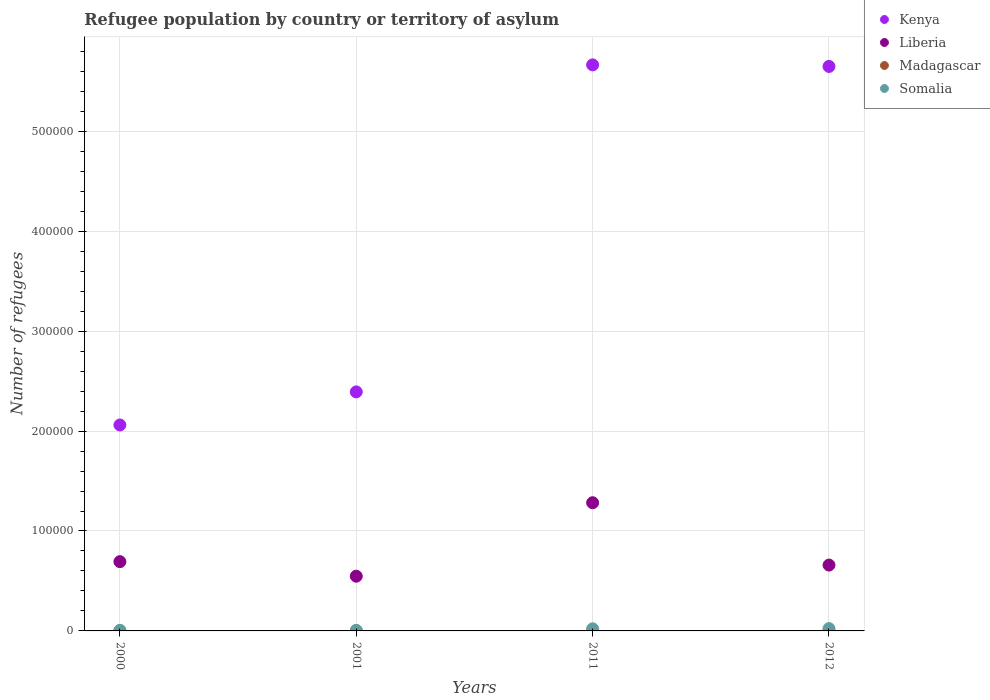How many different coloured dotlines are there?
Make the answer very short. 4. What is the number of refugees in Liberia in 2001?
Provide a succinct answer. 5.48e+04. Across all years, what is the maximum number of refugees in Kenya?
Your answer should be very brief. 5.66e+05. Across all years, what is the minimum number of refugees in Madagascar?
Your answer should be very brief. 9. What is the total number of refugees in Liberia in the graph?
Your response must be concise. 3.18e+05. What is the difference between the number of refugees in Somalia in 2001 and that in 2012?
Your answer should be very brief. -1720. What is the difference between the number of refugees in Liberia in 2000 and the number of refugees in Madagascar in 2012?
Your answer should be compact. 6.93e+04. In the year 2000, what is the difference between the number of refugees in Somalia and number of refugees in Madagascar?
Provide a short and direct response. 508. What is the ratio of the number of refugees in Somalia in 2000 to that in 2012?
Your answer should be compact. 0.24. Is the difference between the number of refugees in Somalia in 2001 and 2012 greater than the difference between the number of refugees in Madagascar in 2001 and 2012?
Your answer should be very brief. No. What is the difference between the highest and the second highest number of refugees in Kenya?
Offer a very short reply. 1554. What is the difference between the highest and the lowest number of refugees in Kenya?
Give a very brief answer. 3.60e+05. In how many years, is the number of refugees in Madagascar greater than the average number of refugees in Madagascar taken over all years?
Ensure brevity in your answer.  2. Is the sum of the number of refugees in Somalia in 2001 and 2012 greater than the maximum number of refugees in Liberia across all years?
Make the answer very short. No. Does the number of refugees in Kenya monotonically increase over the years?
Your response must be concise. No. Is the number of refugees in Liberia strictly less than the number of refugees in Somalia over the years?
Make the answer very short. No. How many dotlines are there?
Offer a terse response. 4. How many years are there in the graph?
Keep it short and to the point. 4. What is the difference between two consecutive major ticks on the Y-axis?
Make the answer very short. 1.00e+05. Are the values on the major ticks of Y-axis written in scientific E-notation?
Provide a short and direct response. No. Does the graph contain grids?
Your response must be concise. Yes. How many legend labels are there?
Your response must be concise. 4. What is the title of the graph?
Your answer should be very brief. Refugee population by country or territory of asylum. Does "Somalia" appear as one of the legend labels in the graph?
Provide a succinct answer. Yes. What is the label or title of the Y-axis?
Your answer should be compact. Number of refugees. What is the Number of refugees in Kenya in 2000?
Provide a short and direct response. 2.06e+05. What is the Number of refugees in Liberia in 2000?
Offer a terse response. 6.93e+04. What is the Number of refugees of Madagascar in 2000?
Your answer should be compact. 50. What is the Number of refugees in Somalia in 2000?
Give a very brief answer. 558. What is the Number of refugees of Kenya in 2001?
Your response must be concise. 2.39e+05. What is the Number of refugees in Liberia in 2001?
Offer a terse response. 5.48e+04. What is the Number of refugees in Madagascar in 2001?
Keep it short and to the point. 34. What is the Number of refugees of Somalia in 2001?
Offer a very short reply. 589. What is the Number of refugees of Kenya in 2011?
Offer a very short reply. 5.66e+05. What is the Number of refugees of Liberia in 2011?
Your response must be concise. 1.28e+05. What is the Number of refugees in Somalia in 2011?
Ensure brevity in your answer.  2099. What is the Number of refugees in Kenya in 2012?
Provide a succinct answer. 5.65e+05. What is the Number of refugees in Liberia in 2012?
Offer a very short reply. 6.59e+04. What is the Number of refugees in Somalia in 2012?
Offer a terse response. 2309. Across all years, what is the maximum Number of refugees of Kenya?
Ensure brevity in your answer.  5.66e+05. Across all years, what is the maximum Number of refugees of Liberia?
Your response must be concise. 1.28e+05. Across all years, what is the maximum Number of refugees in Madagascar?
Provide a short and direct response. 50. Across all years, what is the maximum Number of refugees of Somalia?
Make the answer very short. 2309. Across all years, what is the minimum Number of refugees in Kenya?
Your answer should be very brief. 2.06e+05. Across all years, what is the minimum Number of refugees of Liberia?
Give a very brief answer. 5.48e+04. Across all years, what is the minimum Number of refugees of Madagascar?
Keep it short and to the point. 9. Across all years, what is the minimum Number of refugees of Somalia?
Keep it short and to the point. 558. What is the total Number of refugees of Kenya in the graph?
Offer a terse response. 1.58e+06. What is the total Number of refugees in Liberia in the graph?
Make the answer very short. 3.18e+05. What is the total Number of refugees in Madagascar in the graph?
Give a very brief answer. 102. What is the total Number of refugees of Somalia in the graph?
Your response must be concise. 5555. What is the difference between the Number of refugees in Kenya in 2000 and that in 2001?
Your answer should be compact. -3.31e+04. What is the difference between the Number of refugees in Liberia in 2000 and that in 2001?
Provide a short and direct response. 1.46e+04. What is the difference between the Number of refugees in Madagascar in 2000 and that in 2001?
Give a very brief answer. 16. What is the difference between the Number of refugees of Somalia in 2000 and that in 2001?
Provide a short and direct response. -31. What is the difference between the Number of refugees of Kenya in 2000 and that in 2011?
Your response must be concise. -3.60e+05. What is the difference between the Number of refugees of Liberia in 2000 and that in 2011?
Offer a very short reply. -5.90e+04. What is the difference between the Number of refugees in Madagascar in 2000 and that in 2011?
Ensure brevity in your answer.  41. What is the difference between the Number of refugees in Somalia in 2000 and that in 2011?
Provide a short and direct response. -1541. What is the difference between the Number of refugees in Kenya in 2000 and that in 2012?
Offer a very short reply. -3.59e+05. What is the difference between the Number of refugees of Liberia in 2000 and that in 2012?
Your answer should be compact. 3406. What is the difference between the Number of refugees in Madagascar in 2000 and that in 2012?
Your response must be concise. 41. What is the difference between the Number of refugees of Somalia in 2000 and that in 2012?
Offer a very short reply. -1751. What is the difference between the Number of refugees of Kenya in 2001 and that in 2011?
Offer a very short reply. -3.27e+05. What is the difference between the Number of refugees of Liberia in 2001 and that in 2011?
Make the answer very short. -7.35e+04. What is the difference between the Number of refugees in Madagascar in 2001 and that in 2011?
Make the answer very short. 25. What is the difference between the Number of refugees in Somalia in 2001 and that in 2011?
Ensure brevity in your answer.  -1510. What is the difference between the Number of refugees of Kenya in 2001 and that in 2012?
Ensure brevity in your answer.  -3.26e+05. What is the difference between the Number of refugees of Liberia in 2001 and that in 2012?
Make the answer very short. -1.11e+04. What is the difference between the Number of refugees in Madagascar in 2001 and that in 2012?
Give a very brief answer. 25. What is the difference between the Number of refugees of Somalia in 2001 and that in 2012?
Provide a succinct answer. -1720. What is the difference between the Number of refugees of Kenya in 2011 and that in 2012?
Ensure brevity in your answer.  1554. What is the difference between the Number of refugees in Liberia in 2011 and that in 2012?
Your response must be concise. 6.24e+04. What is the difference between the Number of refugees of Madagascar in 2011 and that in 2012?
Give a very brief answer. 0. What is the difference between the Number of refugees of Somalia in 2011 and that in 2012?
Keep it short and to the point. -210. What is the difference between the Number of refugees in Kenya in 2000 and the Number of refugees in Liberia in 2001?
Provide a short and direct response. 1.51e+05. What is the difference between the Number of refugees of Kenya in 2000 and the Number of refugees of Madagascar in 2001?
Your answer should be very brief. 2.06e+05. What is the difference between the Number of refugees in Kenya in 2000 and the Number of refugees in Somalia in 2001?
Provide a succinct answer. 2.06e+05. What is the difference between the Number of refugees of Liberia in 2000 and the Number of refugees of Madagascar in 2001?
Your response must be concise. 6.93e+04. What is the difference between the Number of refugees in Liberia in 2000 and the Number of refugees in Somalia in 2001?
Offer a terse response. 6.87e+04. What is the difference between the Number of refugees in Madagascar in 2000 and the Number of refugees in Somalia in 2001?
Provide a short and direct response. -539. What is the difference between the Number of refugees in Kenya in 2000 and the Number of refugees in Liberia in 2011?
Keep it short and to the point. 7.78e+04. What is the difference between the Number of refugees of Kenya in 2000 and the Number of refugees of Madagascar in 2011?
Your answer should be compact. 2.06e+05. What is the difference between the Number of refugees in Kenya in 2000 and the Number of refugees in Somalia in 2011?
Ensure brevity in your answer.  2.04e+05. What is the difference between the Number of refugees of Liberia in 2000 and the Number of refugees of Madagascar in 2011?
Offer a very short reply. 6.93e+04. What is the difference between the Number of refugees in Liberia in 2000 and the Number of refugees in Somalia in 2011?
Provide a succinct answer. 6.72e+04. What is the difference between the Number of refugees in Madagascar in 2000 and the Number of refugees in Somalia in 2011?
Provide a short and direct response. -2049. What is the difference between the Number of refugees of Kenya in 2000 and the Number of refugees of Liberia in 2012?
Make the answer very short. 1.40e+05. What is the difference between the Number of refugees in Kenya in 2000 and the Number of refugees in Madagascar in 2012?
Provide a succinct answer. 2.06e+05. What is the difference between the Number of refugees in Kenya in 2000 and the Number of refugees in Somalia in 2012?
Provide a succinct answer. 2.04e+05. What is the difference between the Number of refugees of Liberia in 2000 and the Number of refugees of Madagascar in 2012?
Give a very brief answer. 6.93e+04. What is the difference between the Number of refugees in Liberia in 2000 and the Number of refugees in Somalia in 2012?
Your response must be concise. 6.70e+04. What is the difference between the Number of refugees in Madagascar in 2000 and the Number of refugees in Somalia in 2012?
Your answer should be compact. -2259. What is the difference between the Number of refugees of Kenya in 2001 and the Number of refugees of Liberia in 2011?
Keep it short and to the point. 1.11e+05. What is the difference between the Number of refugees of Kenya in 2001 and the Number of refugees of Madagascar in 2011?
Make the answer very short. 2.39e+05. What is the difference between the Number of refugees of Kenya in 2001 and the Number of refugees of Somalia in 2011?
Give a very brief answer. 2.37e+05. What is the difference between the Number of refugees in Liberia in 2001 and the Number of refugees in Madagascar in 2011?
Keep it short and to the point. 5.48e+04. What is the difference between the Number of refugees of Liberia in 2001 and the Number of refugees of Somalia in 2011?
Your response must be concise. 5.27e+04. What is the difference between the Number of refugees of Madagascar in 2001 and the Number of refugees of Somalia in 2011?
Provide a short and direct response. -2065. What is the difference between the Number of refugees of Kenya in 2001 and the Number of refugees of Liberia in 2012?
Offer a very short reply. 1.73e+05. What is the difference between the Number of refugees of Kenya in 2001 and the Number of refugees of Madagascar in 2012?
Give a very brief answer. 2.39e+05. What is the difference between the Number of refugees in Kenya in 2001 and the Number of refugees in Somalia in 2012?
Provide a short and direct response. 2.37e+05. What is the difference between the Number of refugees in Liberia in 2001 and the Number of refugees in Madagascar in 2012?
Your answer should be very brief. 5.48e+04. What is the difference between the Number of refugees of Liberia in 2001 and the Number of refugees of Somalia in 2012?
Give a very brief answer. 5.25e+04. What is the difference between the Number of refugees in Madagascar in 2001 and the Number of refugees in Somalia in 2012?
Make the answer very short. -2275. What is the difference between the Number of refugees of Kenya in 2011 and the Number of refugees of Liberia in 2012?
Your answer should be very brief. 5.01e+05. What is the difference between the Number of refugees in Kenya in 2011 and the Number of refugees in Madagascar in 2012?
Offer a terse response. 5.66e+05. What is the difference between the Number of refugees of Kenya in 2011 and the Number of refugees of Somalia in 2012?
Give a very brief answer. 5.64e+05. What is the difference between the Number of refugees in Liberia in 2011 and the Number of refugees in Madagascar in 2012?
Keep it short and to the point. 1.28e+05. What is the difference between the Number of refugees of Liberia in 2011 and the Number of refugees of Somalia in 2012?
Give a very brief answer. 1.26e+05. What is the difference between the Number of refugees of Madagascar in 2011 and the Number of refugees of Somalia in 2012?
Ensure brevity in your answer.  -2300. What is the average Number of refugees in Kenya per year?
Make the answer very short. 3.94e+05. What is the average Number of refugees of Liberia per year?
Provide a short and direct response. 7.96e+04. What is the average Number of refugees in Madagascar per year?
Provide a succinct answer. 25.5. What is the average Number of refugees in Somalia per year?
Provide a succinct answer. 1388.75. In the year 2000, what is the difference between the Number of refugees of Kenya and Number of refugees of Liberia?
Keep it short and to the point. 1.37e+05. In the year 2000, what is the difference between the Number of refugees of Kenya and Number of refugees of Madagascar?
Keep it short and to the point. 2.06e+05. In the year 2000, what is the difference between the Number of refugees in Kenya and Number of refugees in Somalia?
Keep it short and to the point. 2.06e+05. In the year 2000, what is the difference between the Number of refugees in Liberia and Number of refugees in Madagascar?
Ensure brevity in your answer.  6.93e+04. In the year 2000, what is the difference between the Number of refugees of Liberia and Number of refugees of Somalia?
Offer a terse response. 6.88e+04. In the year 2000, what is the difference between the Number of refugees of Madagascar and Number of refugees of Somalia?
Keep it short and to the point. -508. In the year 2001, what is the difference between the Number of refugees in Kenya and Number of refugees in Liberia?
Your response must be concise. 1.84e+05. In the year 2001, what is the difference between the Number of refugees in Kenya and Number of refugees in Madagascar?
Your response must be concise. 2.39e+05. In the year 2001, what is the difference between the Number of refugees of Kenya and Number of refugees of Somalia?
Your answer should be compact. 2.39e+05. In the year 2001, what is the difference between the Number of refugees in Liberia and Number of refugees in Madagascar?
Ensure brevity in your answer.  5.47e+04. In the year 2001, what is the difference between the Number of refugees in Liberia and Number of refugees in Somalia?
Make the answer very short. 5.42e+04. In the year 2001, what is the difference between the Number of refugees in Madagascar and Number of refugees in Somalia?
Your answer should be compact. -555. In the year 2011, what is the difference between the Number of refugees of Kenya and Number of refugees of Liberia?
Give a very brief answer. 4.38e+05. In the year 2011, what is the difference between the Number of refugees of Kenya and Number of refugees of Madagascar?
Your answer should be very brief. 5.66e+05. In the year 2011, what is the difference between the Number of refugees in Kenya and Number of refugees in Somalia?
Ensure brevity in your answer.  5.64e+05. In the year 2011, what is the difference between the Number of refugees of Liberia and Number of refugees of Madagascar?
Your response must be concise. 1.28e+05. In the year 2011, what is the difference between the Number of refugees in Liberia and Number of refugees in Somalia?
Offer a very short reply. 1.26e+05. In the year 2011, what is the difference between the Number of refugees of Madagascar and Number of refugees of Somalia?
Your response must be concise. -2090. In the year 2012, what is the difference between the Number of refugees of Kenya and Number of refugees of Liberia?
Provide a succinct answer. 4.99e+05. In the year 2012, what is the difference between the Number of refugees in Kenya and Number of refugees in Madagascar?
Ensure brevity in your answer.  5.65e+05. In the year 2012, what is the difference between the Number of refugees in Kenya and Number of refugees in Somalia?
Offer a terse response. 5.63e+05. In the year 2012, what is the difference between the Number of refugees of Liberia and Number of refugees of Madagascar?
Offer a terse response. 6.59e+04. In the year 2012, what is the difference between the Number of refugees in Liberia and Number of refugees in Somalia?
Keep it short and to the point. 6.36e+04. In the year 2012, what is the difference between the Number of refugees in Madagascar and Number of refugees in Somalia?
Ensure brevity in your answer.  -2300. What is the ratio of the Number of refugees of Kenya in 2000 to that in 2001?
Ensure brevity in your answer.  0.86. What is the ratio of the Number of refugees in Liberia in 2000 to that in 2001?
Offer a terse response. 1.27. What is the ratio of the Number of refugees in Madagascar in 2000 to that in 2001?
Give a very brief answer. 1.47. What is the ratio of the Number of refugees in Kenya in 2000 to that in 2011?
Provide a short and direct response. 0.36. What is the ratio of the Number of refugees in Liberia in 2000 to that in 2011?
Make the answer very short. 0.54. What is the ratio of the Number of refugees in Madagascar in 2000 to that in 2011?
Your response must be concise. 5.56. What is the ratio of the Number of refugees of Somalia in 2000 to that in 2011?
Ensure brevity in your answer.  0.27. What is the ratio of the Number of refugees in Kenya in 2000 to that in 2012?
Offer a terse response. 0.36. What is the ratio of the Number of refugees in Liberia in 2000 to that in 2012?
Provide a short and direct response. 1.05. What is the ratio of the Number of refugees of Madagascar in 2000 to that in 2012?
Your response must be concise. 5.56. What is the ratio of the Number of refugees in Somalia in 2000 to that in 2012?
Provide a succinct answer. 0.24. What is the ratio of the Number of refugees of Kenya in 2001 to that in 2011?
Ensure brevity in your answer.  0.42. What is the ratio of the Number of refugees of Liberia in 2001 to that in 2011?
Offer a very short reply. 0.43. What is the ratio of the Number of refugees of Madagascar in 2001 to that in 2011?
Provide a short and direct response. 3.78. What is the ratio of the Number of refugees in Somalia in 2001 to that in 2011?
Your response must be concise. 0.28. What is the ratio of the Number of refugees in Kenya in 2001 to that in 2012?
Give a very brief answer. 0.42. What is the ratio of the Number of refugees of Liberia in 2001 to that in 2012?
Your answer should be compact. 0.83. What is the ratio of the Number of refugees in Madagascar in 2001 to that in 2012?
Your answer should be compact. 3.78. What is the ratio of the Number of refugees in Somalia in 2001 to that in 2012?
Provide a succinct answer. 0.26. What is the ratio of the Number of refugees of Kenya in 2011 to that in 2012?
Offer a very short reply. 1. What is the ratio of the Number of refugees of Liberia in 2011 to that in 2012?
Offer a terse response. 1.95. What is the ratio of the Number of refugees in Somalia in 2011 to that in 2012?
Give a very brief answer. 0.91. What is the difference between the highest and the second highest Number of refugees of Kenya?
Provide a succinct answer. 1554. What is the difference between the highest and the second highest Number of refugees of Liberia?
Offer a terse response. 5.90e+04. What is the difference between the highest and the second highest Number of refugees in Madagascar?
Your answer should be compact. 16. What is the difference between the highest and the second highest Number of refugees in Somalia?
Provide a short and direct response. 210. What is the difference between the highest and the lowest Number of refugees of Kenya?
Make the answer very short. 3.60e+05. What is the difference between the highest and the lowest Number of refugees in Liberia?
Provide a succinct answer. 7.35e+04. What is the difference between the highest and the lowest Number of refugees of Somalia?
Your answer should be compact. 1751. 